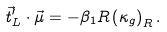Convert formula to latex. <formula><loc_0><loc_0><loc_500><loc_500>\vec { t } ^ { \prime } _ { L } \cdot \vec { \mu } = - \beta _ { 1 } R \left ( \kappa _ { g } \right ) _ { R } .</formula> 